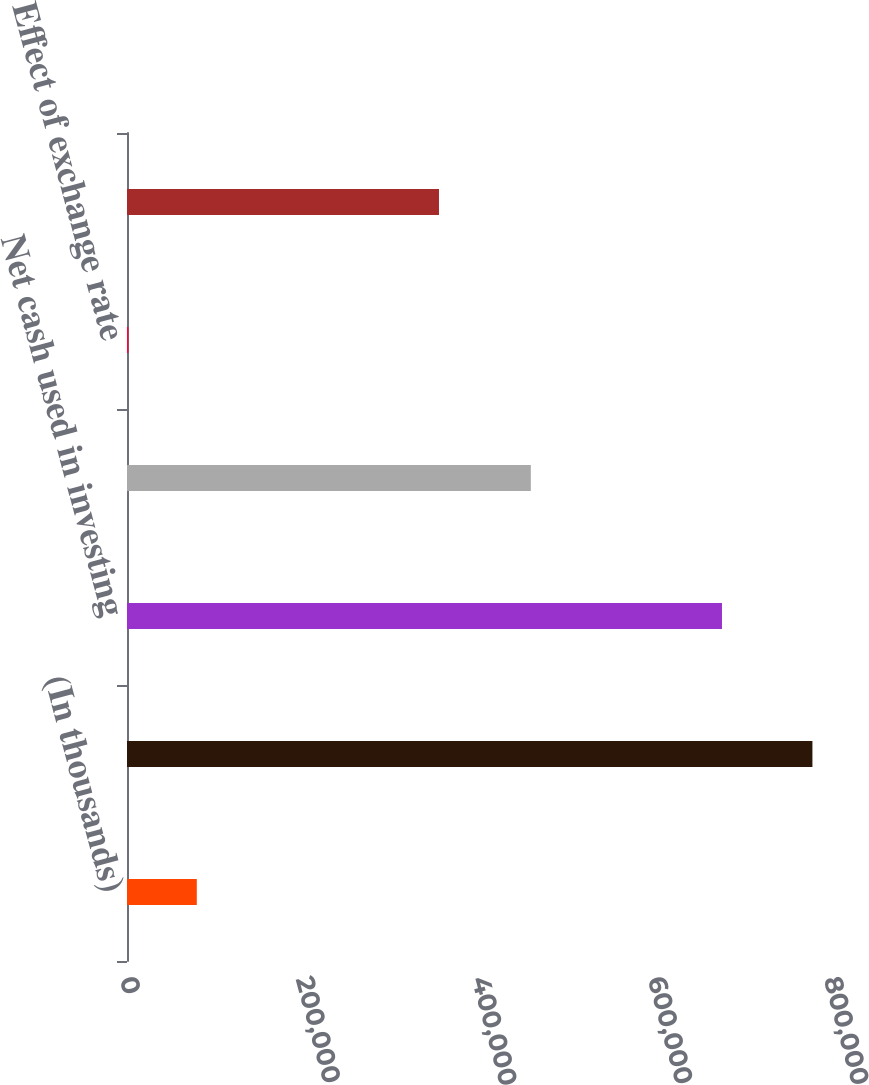Convert chart to OTSL. <chart><loc_0><loc_0><loc_500><loc_500><bar_chart><fcel>(In thousands)<fcel>Net cash provided by operating<fcel>Net cash used in investing<fcel>Net cash used in financing<fcel>Effect of exchange rate<fcel>Net increase (decrease) in<nl><fcel>79311.5<fcel>778886<fcel>676109<fcel>458887<fcel>1581<fcel>354529<nl></chart> 